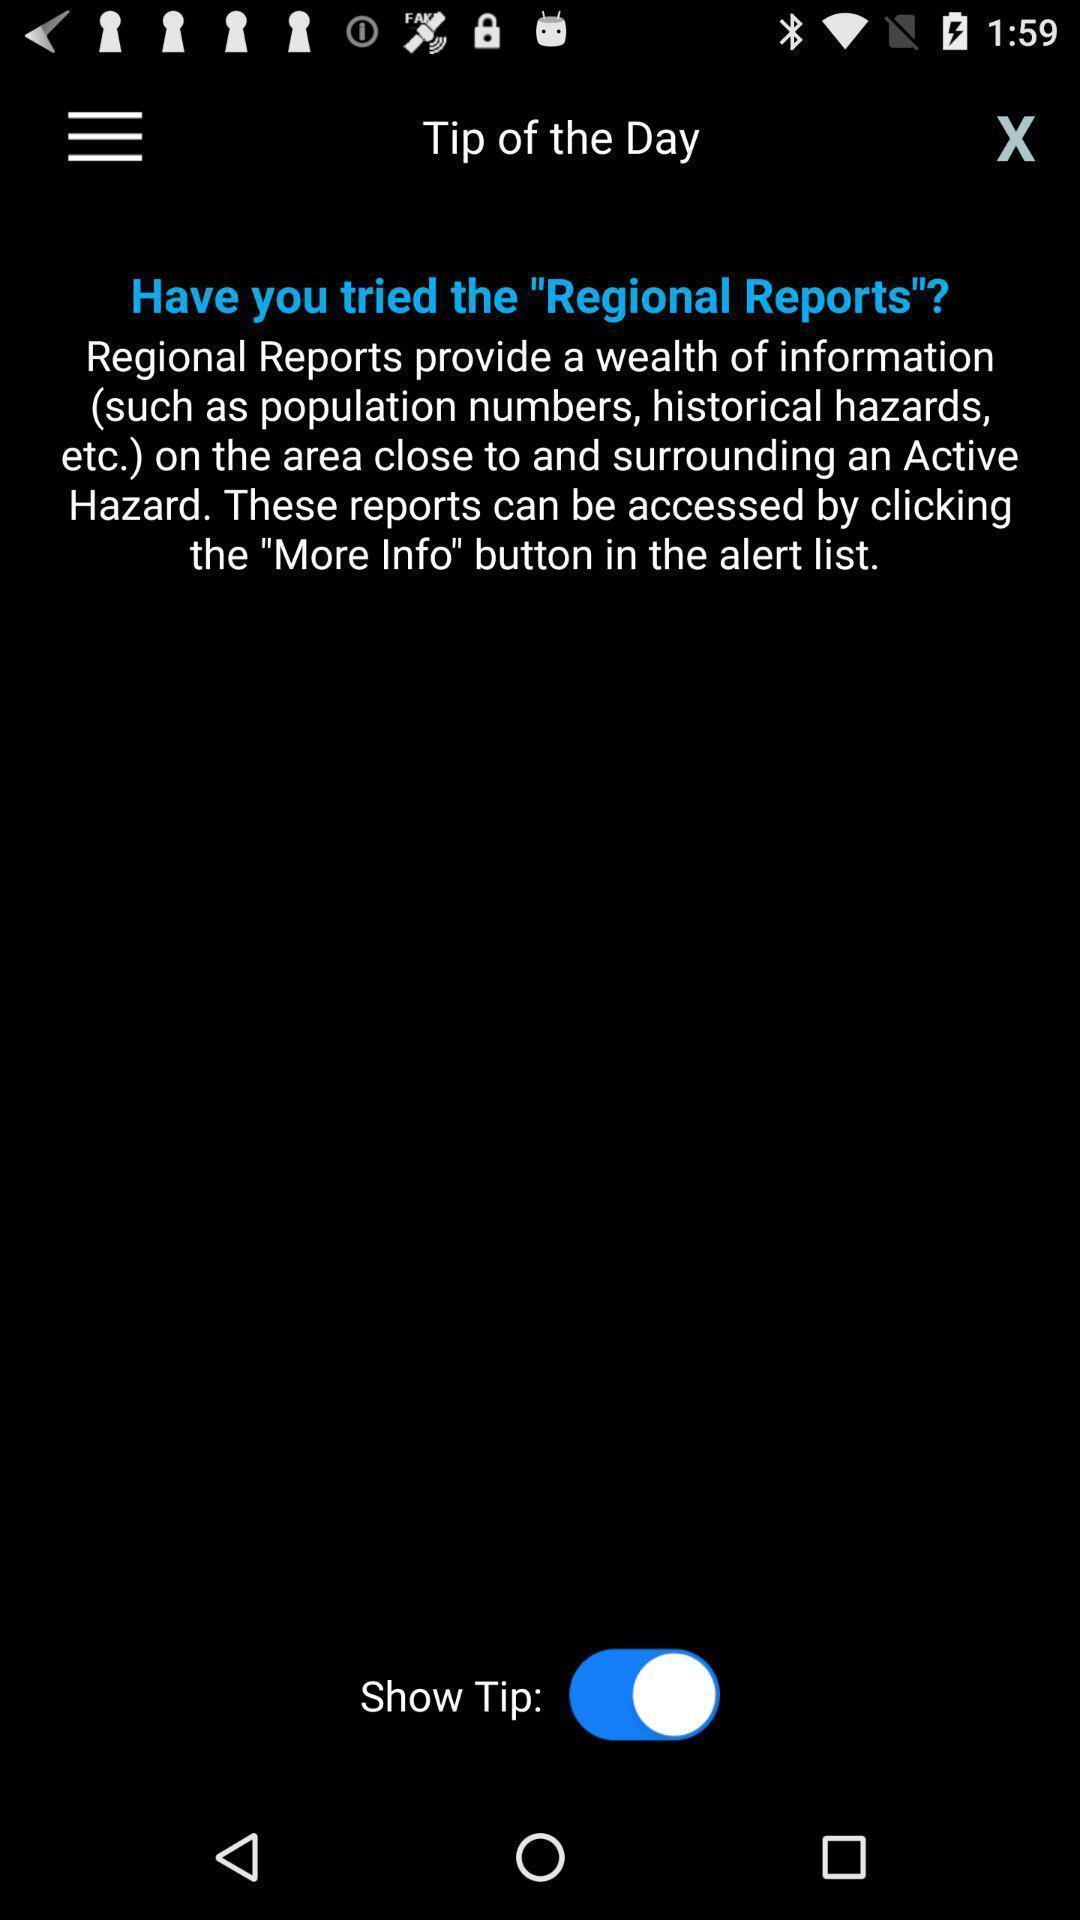Give me a narrative description of this picture. Tip of the day regional reports with information. 